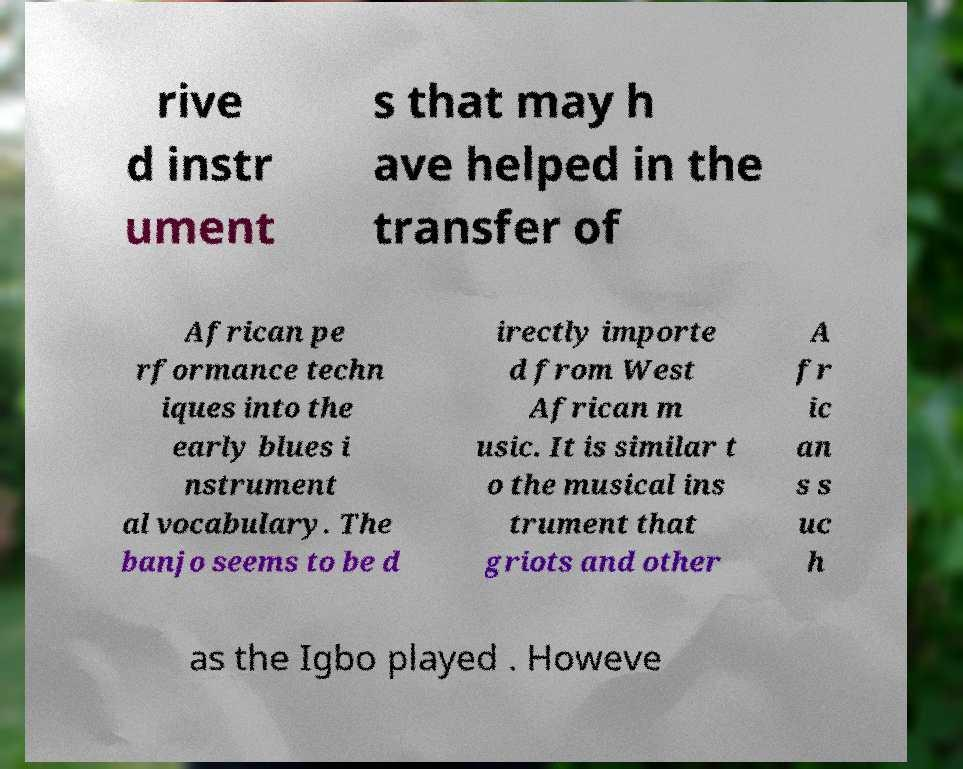What messages or text are displayed in this image? I need them in a readable, typed format. rive d instr ument s that may h ave helped in the transfer of African pe rformance techn iques into the early blues i nstrument al vocabulary. The banjo seems to be d irectly importe d from West African m usic. It is similar t o the musical ins trument that griots and other A fr ic an s s uc h as the Igbo played . Howeve 